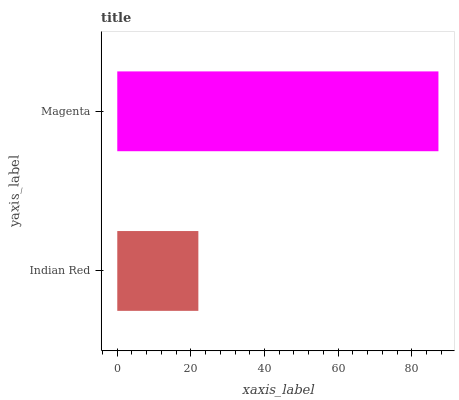Is Indian Red the minimum?
Answer yes or no. Yes. Is Magenta the maximum?
Answer yes or no. Yes. Is Magenta the minimum?
Answer yes or no. No. Is Magenta greater than Indian Red?
Answer yes or no. Yes. Is Indian Red less than Magenta?
Answer yes or no. Yes. Is Indian Red greater than Magenta?
Answer yes or no. No. Is Magenta less than Indian Red?
Answer yes or no. No. Is Magenta the high median?
Answer yes or no. Yes. Is Indian Red the low median?
Answer yes or no. Yes. Is Indian Red the high median?
Answer yes or no. No. Is Magenta the low median?
Answer yes or no. No. 